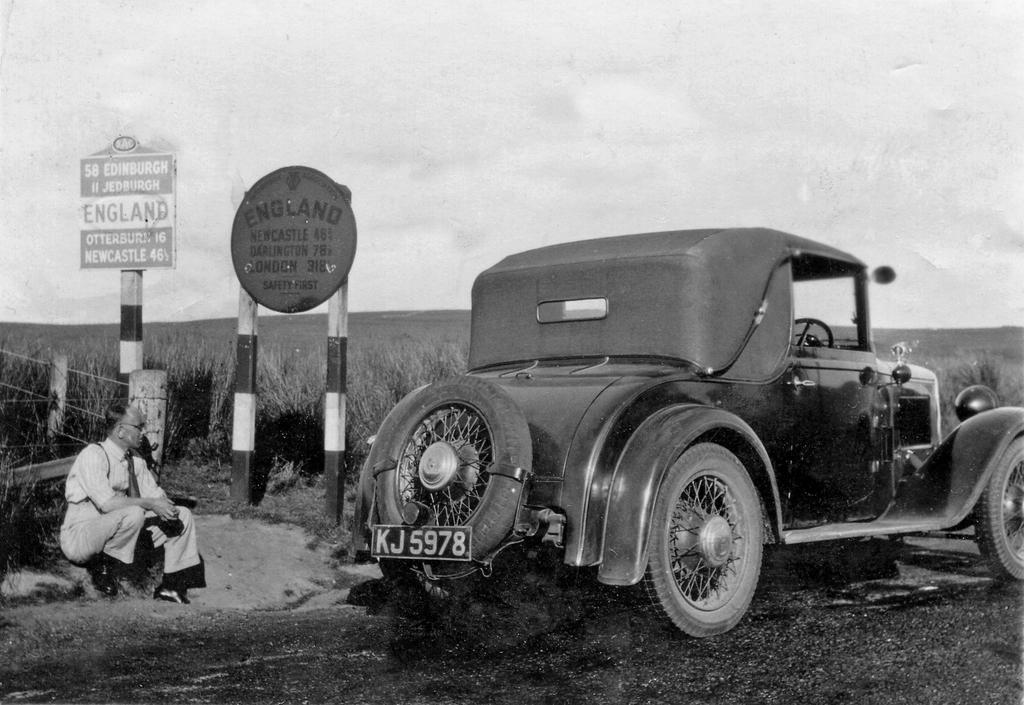What is the person in the image doing? There is a person sitting on the ground in the image. What type of vehicle can be seen in the image? There is a motor vehicle in the image. What type of signs are present in the image? Sign boards and information boards are visible in the image. What is the purpose of the fence in the image? The fence is present in the image, but its purpose is not explicitly stated. What can be seen in the sky in the image? The sky is visible in the image. What type of location is depicted in the image? There is an agricultural farm in the image. What emotion is the person expressing in the image? The image does not provide enough information to determine the person's emotional state. What type of animal can be seen grazing in the agricultural farm in the image? There are no animals visible in the image. 